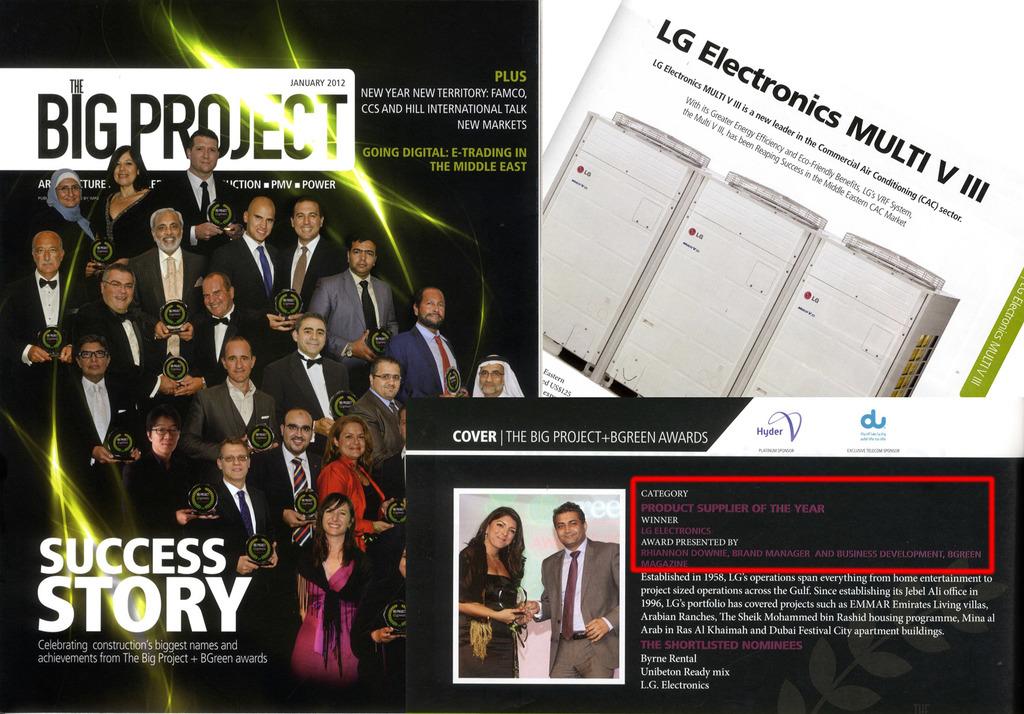What is the project they are working on?
Offer a terse response. The big project. What is the title of the magazine?
Provide a short and direct response. Big project. 